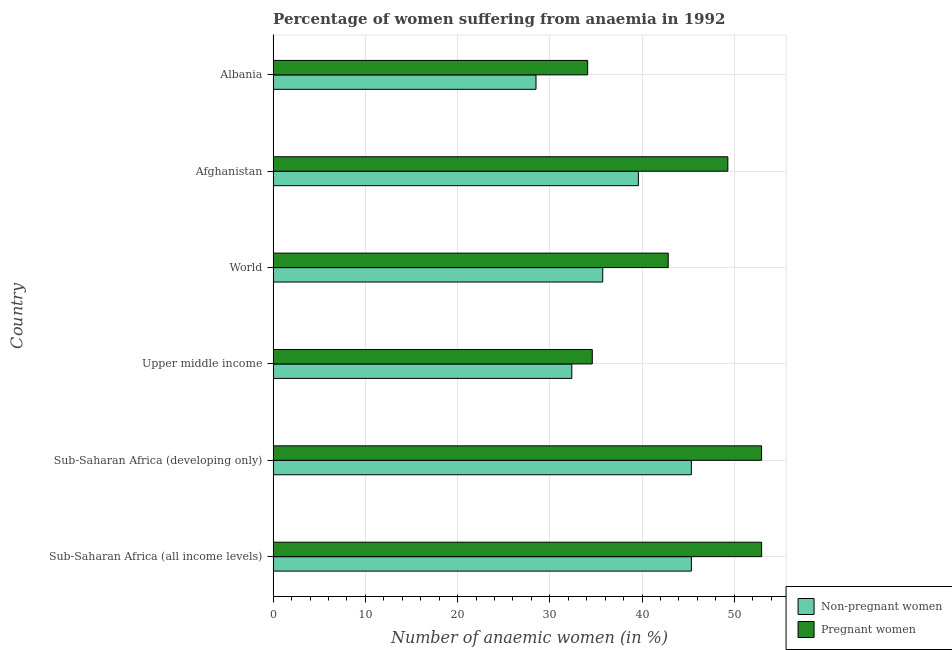How many different coloured bars are there?
Provide a short and direct response. 2. Are the number of bars per tick equal to the number of legend labels?
Your answer should be compact. Yes. How many bars are there on the 1st tick from the top?
Give a very brief answer. 2. What is the label of the 4th group of bars from the top?
Ensure brevity in your answer.  Upper middle income. In how many cases, is the number of bars for a given country not equal to the number of legend labels?
Keep it short and to the point. 0. What is the percentage of non-pregnant anaemic women in Albania?
Ensure brevity in your answer.  28.5. Across all countries, what is the maximum percentage of non-pregnant anaemic women?
Offer a terse response. 45.34. Across all countries, what is the minimum percentage of pregnant anaemic women?
Your answer should be very brief. 34.1. In which country was the percentage of non-pregnant anaemic women maximum?
Ensure brevity in your answer.  Sub-Saharan Africa (all income levels). In which country was the percentage of non-pregnant anaemic women minimum?
Make the answer very short. Albania. What is the total percentage of pregnant anaemic women in the graph?
Offer a very short reply. 266.76. What is the difference between the percentage of pregnant anaemic women in Afghanistan and that in World?
Provide a short and direct response. 6.46. What is the difference between the percentage of non-pregnant anaemic women in Sub-Saharan Africa (developing only) and the percentage of pregnant anaemic women in Afghanistan?
Ensure brevity in your answer.  -3.96. What is the average percentage of pregnant anaemic women per country?
Offer a terse response. 44.46. What is the difference between the percentage of pregnant anaemic women and percentage of non-pregnant anaemic women in World?
Keep it short and to the point. 7.1. In how many countries, is the percentage of pregnant anaemic women greater than 6 %?
Keep it short and to the point. 6. Is the percentage of pregnant anaemic women in Afghanistan less than that in Albania?
Offer a very short reply. No. Is the difference between the percentage of non-pregnant anaemic women in Albania and Sub-Saharan Africa (all income levels) greater than the difference between the percentage of pregnant anaemic women in Albania and Sub-Saharan Africa (all income levels)?
Your answer should be compact. Yes. What is the difference between the highest and the second highest percentage of non-pregnant anaemic women?
Provide a short and direct response. 0. What is the difference between the highest and the lowest percentage of pregnant anaemic women?
Make the answer very short. 18.86. Is the sum of the percentage of non-pregnant anaemic women in Sub-Saharan Africa (all income levels) and Sub-Saharan Africa (developing only) greater than the maximum percentage of pregnant anaemic women across all countries?
Your answer should be compact. Yes. What does the 1st bar from the top in Sub-Saharan Africa (all income levels) represents?
Your answer should be compact. Pregnant women. What does the 1st bar from the bottom in Albania represents?
Your response must be concise. Non-pregnant women. How many bars are there?
Provide a succinct answer. 12. Are all the bars in the graph horizontal?
Offer a very short reply. Yes. What is the difference between two consecutive major ticks on the X-axis?
Offer a terse response. 10. How many legend labels are there?
Make the answer very short. 2. How are the legend labels stacked?
Provide a short and direct response. Vertical. What is the title of the graph?
Provide a short and direct response. Percentage of women suffering from anaemia in 1992. What is the label or title of the X-axis?
Your answer should be compact. Number of anaemic women (in %). What is the label or title of the Y-axis?
Give a very brief answer. Country. What is the Number of anaemic women (in %) of Non-pregnant women in Sub-Saharan Africa (all income levels)?
Give a very brief answer. 45.34. What is the Number of anaemic women (in %) in Pregnant women in Sub-Saharan Africa (all income levels)?
Offer a terse response. 52.96. What is the Number of anaemic women (in %) in Non-pregnant women in Sub-Saharan Africa (developing only)?
Your answer should be compact. 45.34. What is the Number of anaemic women (in %) of Pregnant women in Sub-Saharan Africa (developing only)?
Your answer should be compact. 52.96. What is the Number of anaemic women (in %) of Non-pregnant women in Upper middle income?
Keep it short and to the point. 32.38. What is the Number of anaemic women (in %) of Pregnant women in Upper middle income?
Provide a succinct answer. 34.6. What is the Number of anaemic women (in %) of Non-pregnant women in World?
Keep it short and to the point. 35.74. What is the Number of anaemic women (in %) in Pregnant women in World?
Your answer should be compact. 42.84. What is the Number of anaemic women (in %) of Non-pregnant women in Afghanistan?
Your answer should be compact. 39.6. What is the Number of anaemic women (in %) in Pregnant women in Afghanistan?
Make the answer very short. 49.3. What is the Number of anaemic women (in %) of Pregnant women in Albania?
Your answer should be compact. 34.1. Across all countries, what is the maximum Number of anaemic women (in %) of Non-pregnant women?
Keep it short and to the point. 45.34. Across all countries, what is the maximum Number of anaemic women (in %) of Pregnant women?
Provide a short and direct response. 52.96. Across all countries, what is the minimum Number of anaemic women (in %) of Non-pregnant women?
Provide a succinct answer. 28.5. Across all countries, what is the minimum Number of anaemic women (in %) in Pregnant women?
Make the answer very short. 34.1. What is the total Number of anaemic women (in %) of Non-pregnant women in the graph?
Your response must be concise. 226.91. What is the total Number of anaemic women (in %) of Pregnant women in the graph?
Ensure brevity in your answer.  266.76. What is the difference between the Number of anaemic women (in %) in Non-pregnant women in Sub-Saharan Africa (all income levels) and that in Sub-Saharan Africa (developing only)?
Ensure brevity in your answer.  0. What is the difference between the Number of anaemic women (in %) in Pregnant women in Sub-Saharan Africa (all income levels) and that in Sub-Saharan Africa (developing only)?
Offer a terse response. 0. What is the difference between the Number of anaemic women (in %) of Non-pregnant women in Sub-Saharan Africa (all income levels) and that in Upper middle income?
Ensure brevity in your answer.  12.96. What is the difference between the Number of anaemic women (in %) of Pregnant women in Sub-Saharan Africa (all income levels) and that in Upper middle income?
Offer a very short reply. 18.36. What is the difference between the Number of anaemic women (in %) in Non-pregnant women in Sub-Saharan Africa (all income levels) and that in World?
Provide a short and direct response. 9.61. What is the difference between the Number of anaemic women (in %) in Pregnant women in Sub-Saharan Africa (all income levels) and that in World?
Your answer should be compact. 10.13. What is the difference between the Number of anaemic women (in %) in Non-pregnant women in Sub-Saharan Africa (all income levels) and that in Afghanistan?
Provide a succinct answer. 5.74. What is the difference between the Number of anaemic women (in %) of Pregnant women in Sub-Saharan Africa (all income levels) and that in Afghanistan?
Ensure brevity in your answer.  3.66. What is the difference between the Number of anaemic women (in %) of Non-pregnant women in Sub-Saharan Africa (all income levels) and that in Albania?
Make the answer very short. 16.84. What is the difference between the Number of anaemic women (in %) in Pregnant women in Sub-Saharan Africa (all income levels) and that in Albania?
Your answer should be compact. 18.86. What is the difference between the Number of anaemic women (in %) in Non-pregnant women in Sub-Saharan Africa (developing only) and that in Upper middle income?
Give a very brief answer. 12.96. What is the difference between the Number of anaemic women (in %) in Pregnant women in Sub-Saharan Africa (developing only) and that in Upper middle income?
Offer a very short reply. 18.36. What is the difference between the Number of anaemic women (in %) of Non-pregnant women in Sub-Saharan Africa (developing only) and that in World?
Provide a succinct answer. 9.61. What is the difference between the Number of anaemic women (in %) in Pregnant women in Sub-Saharan Africa (developing only) and that in World?
Offer a very short reply. 10.12. What is the difference between the Number of anaemic women (in %) in Non-pregnant women in Sub-Saharan Africa (developing only) and that in Afghanistan?
Your response must be concise. 5.74. What is the difference between the Number of anaemic women (in %) in Pregnant women in Sub-Saharan Africa (developing only) and that in Afghanistan?
Ensure brevity in your answer.  3.66. What is the difference between the Number of anaemic women (in %) in Non-pregnant women in Sub-Saharan Africa (developing only) and that in Albania?
Provide a succinct answer. 16.84. What is the difference between the Number of anaemic women (in %) in Pregnant women in Sub-Saharan Africa (developing only) and that in Albania?
Give a very brief answer. 18.86. What is the difference between the Number of anaemic women (in %) of Non-pregnant women in Upper middle income and that in World?
Your answer should be compact. -3.35. What is the difference between the Number of anaemic women (in %) of Pregnant women in Upper middle income and that in World?
Keep it short and to the point. -8.23. What is the difference between the Number of anaemic women (in %) in Non-pregnant women in Upper middle income and that in Afghanistan?
Your response must be concise. -7.22. What is the difference between the Number of anaemic women (in %) in Pregnant women in Upper middle income and that in Afghanistan?
Your answer should be compact. -14.7. What is the difference between the Number of anaemic women (in %) in Non-pregnant women in Upper middle income and that in Albania?
Your answer should be very brief. 3.88. What is the difference between the Number of anaemic women (in %) in Pregnant women in Upper middle income and that in Albania?
Your answer should be very brief. 0.5. What is the difference between the Number of anaemic women (in %) in Non-pregnant women in World and that in Afghanistan?
Your response must be concise. -3.86. What is the difference between the Number of anaemic women (in %) of Pregnant women in World and that in Afghanistan?
Make the answer very short. -6.46. What is the difference between the Number of anaemic women (in %) of Non-pregnant women in World and that in Albania?
Provide a short and direct response. 7.24. What is the difference between the Number of anaemic women (in %) in Pregnant women in World and that in Albania?
Give a very brief answer. 8.74. What is the difference between the Number of anaemic women (in %) in Non-pregnant women in Afghanistan and that in Albania?
Keep it short and to the point. 11.1. What is the difference between the Number of anaemic women (in %) of Pregnant women in Afghanistan and that in Albania?
Your answer should be compact. 15.2. What is the difference between the Number of anaemic women (in %) in Non-pregnant women in Sub-Saharan Africa (all income levels) and the Number of anaemic women (in %) in Pregnant women in Sub-Saharan Africa (developing only)?
Give a very brief answer. -7.61. What is the difference between the Number of anaemic women (in %) in Non-pregnant women in Sub-Saharan Africa (all income levels) and the Number of anaemic women (in %) in Pregnant women in Upper middle income?
Provide a succinct answer. 10.74. What is the difference between the Number of anaemic women (in %) in Non-pregnant women in Sub-Saharan Africa (all income levels) and the Number of anaemic women (in %) in Pregnant women in World?
Offer a terse response. 2.51. What is the difference between the Number of anaemic women (in %) in Non-pregnant women in Sub-Saharan Africa (all income levels) and the Number of anaemic women (in %) in Pregnant women in Afghanistan?
Provide a short and direct response. -3.96. What is the difference between the Number of anaemic women (in %) in Non-pregnant women in Sub-Saharan Africa (all income levels) and the Number of anaemic women (in %) in Pregnant women in Albania?
Give a very brief answer. 11.24. What is the difference between the Number of anaemic women (in %) of Non-pregnant women in Sub-Saharan Africa (developing only) and the Number of anaemic women (in %) of Pregnant women in Upper middle income?
Make the answer very short. 10.74. What is the difference between the Number of anaemic women (in %) of Non-pregnant women in Sub-Saharan Africa (developing only) and the Number of anaemic women (in %) of Pregnant women in World?
Give a very brief answer. 2.51. What is the difference between the Number of anaemic women (in %) of Non-pregnant women in Sub-Saharan Africa (developing only) and the Number of anaemic women (in %) of Pregnant women in Afghanistan?
Offer a terse response. -3.96. What is the difference between the Number of anaemic women (in %) of Non-pregnant women in Sub-Saharan Africa (developing only) and the Number of anaemic women (in %) of Pregnant women in Albania?
Your answer should be compact. 11.24. What is the difference between the Number of anaemic women (in %) in Non-pregnant women in Upper middle income and the Number of anaemic women (in %) in Pregnant women in World?
Provide a succinct answer. -10.45. What is the difference between the Number of anaemic women (in %) in Non-pregnant women in Upper middle income and the Number of anaemic women (in %) in Pregnant women in Afghanistan?
Make the answer very short. -16.92. What is the difference between the Number of anaemic women (in %) of Non-pregnant women in Upper middle income and the Number of anaemic women (in %) of Pregnant women in Albania?
Make the answer very short. -1.72. What is the difference between the Number of anaemic women (in %) of Non-pregnant women in World and the Number of anaemic women (in %) of Pregnant women in Afghanistan?
Provide a succinct answer. -13.56. What is the difference between the Number of anaemic women (in %) of Non-pregnant women in World and the Number of anaemic women (in %) of Pregnant women in Albania?
Your response must be concise. 1.64. What is the difference between the Number of anaemic women (in %) of Non-pregnant women in Afghanistan and the Number of anaemic women (in %) of Pregnant women in Albania?
Offer a terse response. 5.5. What is the average Number of anaemic women (in %) of Non-pregnant women per country?
Give a very brief answer. 37.82. What is the average Number of anaemic women (in %) in Pregnant women per country?
Offer a very short reply. 44.46. What is the difference between the Number of anaemic women (in %) in Non-pregnant women and Number of anaemic women (in %) in Pregnant women in Sub-Saharan Africa (all income levels)?
Your answer should be compact. -7.62. What is the difference between the Number of anaemic women (in %) in Non-pregnant women and Number of anaemic women (in %) in Pregnant women in Sub-Saharan Africa (developing only)?
Give a very brief answer. -7.62. What is the difference between the Number of anaemic women (in %) of Non-pregnant women and Number of anaemic women (in %) of Pregnant women in Upper middle income?
Ensure brevity in your answer.  -2.22. What is the difference between the Number of anaemic women (in %) of Non-pregnant women and Number of anaemic women (in %) of Pregnant women in World?
Provide a short and direct response. -7.1. What is the difference between the Number of anaemic women (in %) in Non-pregnant women and Number of anaemic women (in %) in Pregnant women in Afghanistan?
Give a very brief answer. -9.7. What is the difference between the Number of anaemic women (in %) of Non-pregnant women and Number of anaemic women (in %) of Pregnant women in Albania?
Provide a short and direct response. -5.6. What is the ratio of the Number of anaemic women (in %) in Pregnant women in Sub-Saharan Africa (all income levels) to that in Sub-Saharan Africa (developing only)?
Provide a succinct answer. 1. What is the ratio of the Number of anaemic women (in %) in Non-pregnant women in Sub-Saharan Africa (all income levels) to that in Upper middle income?
Give a very brief answer. 1.4. What is the ratio of the Number of anaemic women (in %) of Pregnant women in Sub-Saharan Africa (all income levels) to that in Upper middle income?
Give a very brief answer. 1.53. What is the ratio of the Number of anaemic women (in %) of Non-pregnant women in Sub-Saharan Africa (all income levels) to that in World?
Offer a terse response. 1.27. What is the ratio of the Number of anaemic women (in %) of Pregnant women in Sub-Saharan Africa (all income levels) to that in World?
Provide a short and direct response. 1.24. What is the ratio of the Number of anaemic women (in %) in Non-pregnant women in Sub-Saharan Africa (all income levels) to that in Afghanistan?
Offer a very short reply. 1.15. What is the ratio of the Number of anaemic women (in %) in Pregnant women in Sub-Saharan Africa (all income levels) to that in Afghanistan?
Provide a succinct answer. 1.07. What is the ratio of the Number of anaemic women (in %) of Non-pregnant women in Sub-Saharan Africa (all income levels) to that in Albania?
Provide a short and direct response. 1.59. What is the ratio of the Number of anaemic women (in %) in Pregnant women in Sub-Saharan Africa (all income levels) to that in Albania?
Ensure brevity in your answer.  1.55. What is the ratio of the Number of anaemic women (in %) of Non-pregnant women in Sub-Saharan Africa (developing only) to that in Upper middle income?
Provide a short and direct response. 1.4. What is the ratio of the Number of anaemic women (in %) of Pregnant women in Sub-Saharan Africa (developing only) to that in Upper middle income?
Give a very brief answer. 1.53. What is the ratio of the Number of anaemic women (in %) in Non-pregnant women in Sub-Saharan Africa (developing only) to that in World?
Provide a succinct answer. 1.27. What is the ratio of the Number of anaemic women (in %) of Pregnant women in Sub-Saharan Africa (developing only) to that in World?
Keep it short and to the point. 1.24. What is the ratio of the Number of anaemic women (in %) in Non-pregnant women in Sub-Saharan Africa (developing only) to that in Afghanistan?
Keep it short and to the point. 1.15. What is the ratio of the Number of anaemic women (in %) of Pregnant women in Sub-Saharan Africa (developing only) to that in Afghanistan?
Your answer should be very brief. 1.07. What is the ratio of the Number of anaemic women (in %) in Non-pregnant women in Sub-Saharan Africa (developing only) to that in Albania?
Make the answer very short. 1.59. What is the ratio of the Number of anaemic women (in %) of Pregnant women in Sub-Saharan Africa (developing only) to that in Albania?
Offer a terse response. 1.55. What is the ratio of the Number of anaemic women (in %) of Non-pregnant women in Upper middle income to that in World?
Keep it short and to the point. 0.91. What is the ratio of the Number of anaemic women (in %) in Pregnant women in Upper middle income to that in World?
Your answer should be very brief. 0.81. What is the ratio of the Number of anaemic women (in %) of Non-pregnant women in Upper middle income to that in Afghanistan?
Give a very brief answer. 0.82. What is the ratio of the Number of anaemic women (in %) in Pregnant women in Upper middle income to that in Afghanistan?
Offer a terse response. 0.7. What is the ratio of the Number of anaemic women (in %) of Non-pregnant women in Upper middle income to that in Albania?
Give a very brief answer. 1.14. What is the ratio of the Number of anaemic women (in %) of Pregnant women in Upper middle income to that in Albania?
Make the answer very short. 1.01. What is the ratio of the Number of anaemic women (in %) of Non-pregnant women in World to that in Afghanistan?
Make the answer very short. 0.9. What is the ratio of the Number of anaemic women (in %) in Pregnant women in World to that in Afghanistan?
Offer a terse response. 0.87. What is the ratio of the Number of anaemic women (in %) of Non-pregnant women in World to that in Albania?
Offer a very short reply. 1.25. What is the ratio of the Number of anaemic women (in %) in Pregnant women in World to that in Albania?
Provide a short and direct response. 1.26. What is the ratio of the Number of anaemic women (in %) in Non-pregnant women in Afghanistan to that in Albania?
Your answer should be compact. 1.39. What is the ratio of the Number of anaemic women (in %) in Pregnant women in Afghanistan to that in Albania?
Offer a very short reply. 1.45. What is the difference between the highest and the second highest Number of anaemic women (in %) in Non-pregnant women?
Give a very brief answer. 0. What is the difference between the highest and the second highest Number of anaemic women (in %) in Pregnant women?
Provide a succinct answer. 0. What is the difference between the highest and the lowest Number of anaemic women (in %) in Non-pregnant women?
Provide a short and direct response. 16.84. What is the difference between the highest and the lowest Number of anaemic women (in %) in Pregnant women?
Make the answer very short. 18.86. 